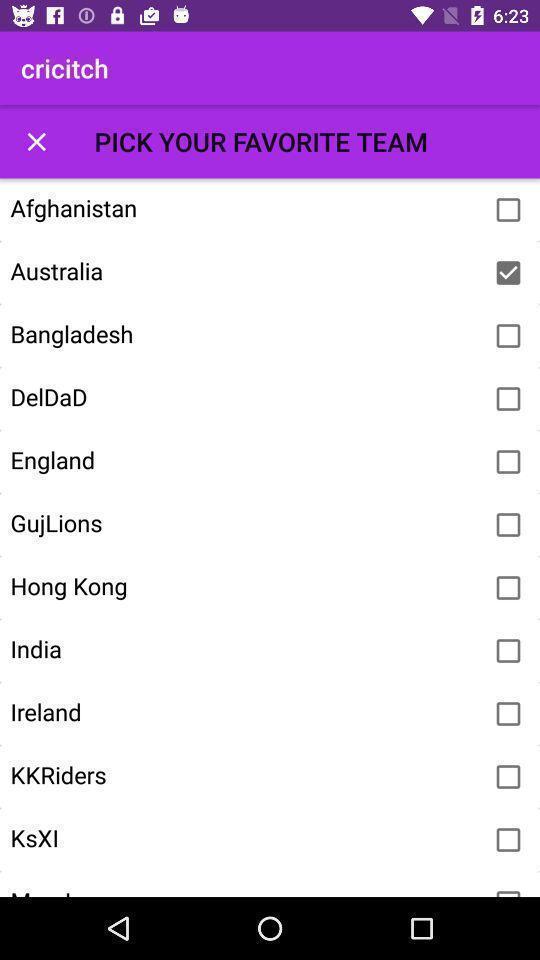Explain the elements present in this screenshot. Screen showing list of various teams in gaming app. 